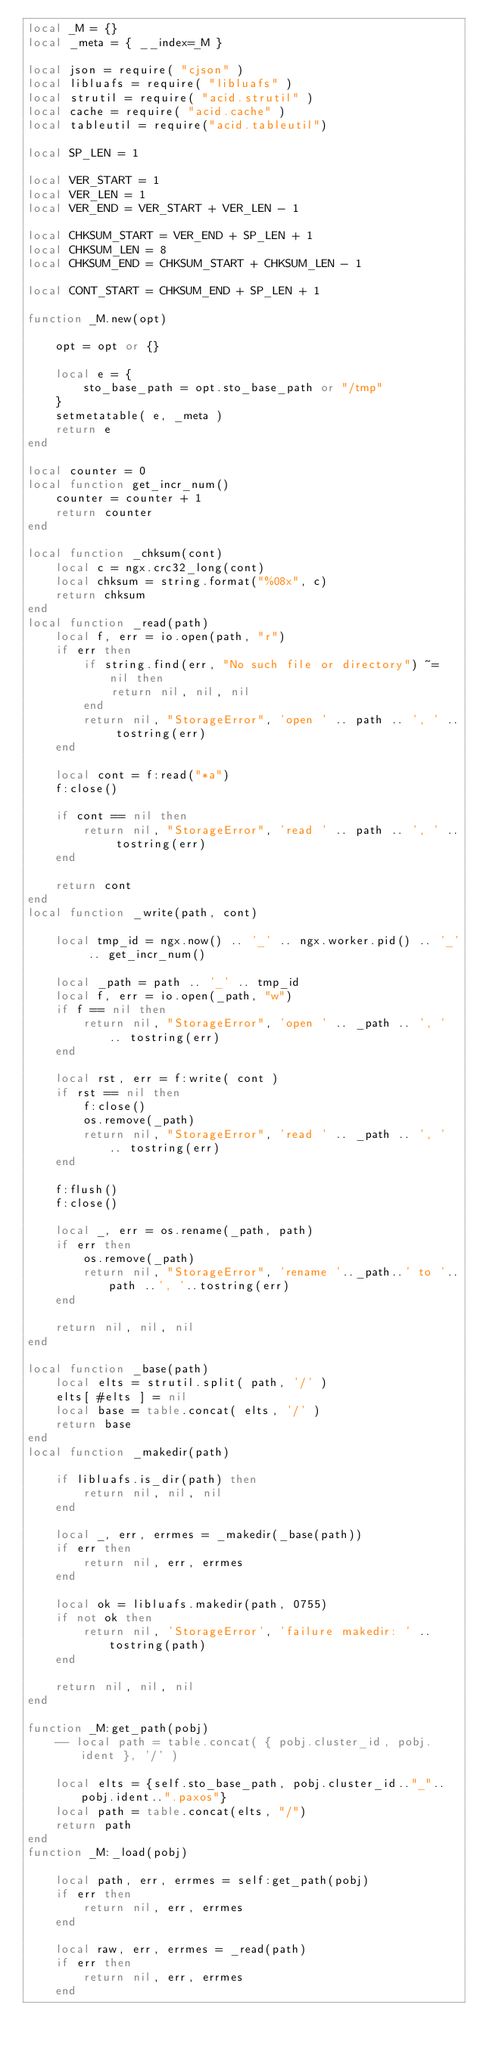<code> <loc_0><loc_0><loc_500><loc_500><_Lua_>local _M = {}
local _meta = { __index=_M }

local json = require( "cjson" )
local libluafs = require( "libluafs" )
local strutil = require( "acid.strutil" )
local cache = require( "acid.cache" )
local tableutil = require("acid.tableutil")

local SP_LEN = 1

local VER_START = 1
local VER_LEN = 1
local VER_END = VER_START + VER_LEN - 1

local CHKSUM_START = VER_END + SP_LEN + 1
local CHKSUM_LEN = 8
local CHKSUM_END = CHKSUM_START + CHKSUM_LEN - 1

local CONT_START = CHKSUM_END + SP_LEN + 1

function _M.new(opt)

    opt = opt or {}

    local e = {
        sto_base_path = opt.sto_base_path or "/tmp"
    }
    setmetatable( e, _meta )
    return e
end

local counter = 0
local function get_incr_num()
    counter = counter + 1
    return counter
end

local function _chksum(cont)
    local c = ngx.crc32_long(cont)
    local chksum = string.format("%08x", c)
    return chksum
end
local function _read(path)
    local f, err = io.open(path, "r")
    if err then
        if string.find(err, "No such file or directory") ~= nil then
            return nil, nil, nil
        end
        return nil, "StorageError", 'open ' .. path .. ', ' .. tostring(err)
    end

    local cont = f:read("*a")
    f:close()

    if cont == nil then
        return nil, "StorageError", 'read ' .. path .. ', ' .. tostring(err)
    end

    return cont
end
local function _write(path, cont)

    local tmp_id = ngx.now() .. '_' .. ngx.worker.pid() .. '_' .. get_incr_num()

    local _path = path .. '_' .. tmp_id
    local f, err = io.open(_path, "w")
    if f == nil then
        return nil, "StorageError", 'open ' .. _path .. ', ' .. tostring(err)
    end

    local rst, err = f:write( cont )
    if rst == nil then
        f:close()
        os.remove(_path)
        return nil, "StorageError", 'read ' .. _path .. ', ' .. tostring(err)
    end

    f:flush()
    f:close()

    local _, err = os.rename(_path, path)
    if err then
        os.remove(_path)
        return nil, "StorageError", 'rename '.._path..' to '..path ..', '..tostring(err)
    end

    return nil, nil, nil
end

local function _base(path)
    local elts = strutil.split( path, '/' )
    elts[ #elts ] = nil
    local base = table.concat( elts, '/' )
    return base
end
local function _makedir(path)

    if libluafs.is_dir(path) then
        return nil, nil, nil
    end

    local _, err, errmes = _makedir(_base(path))
    if err then
        return nil, err, errmes
    end

    local ok = libluafs.makedir(path, 0755)
    if not ok then
        return nil, 'StorageError', 'failure makedir: ' .. tostring(path)
    end

    return nil, nil, nil
end

function _M:get_path(pobj)
    -- local path = table.concat( { pobj.cluster_id, pobj.ident }, '/' )

    local elts = {self.sto_base_path, pobj.cluster_id.."_"..pobj.ident..".paxos"}
    local path = table.concat(elts, "/")
    return path
end
function _M:_load(pobj)

    local path, err, errmes = self:get_path(pobj)
    if err then
        return nil, err, errmes
    end

    local raw, err, errmes = _read(path)
    if err then
        return nil, err, errmes
    end
</code> 